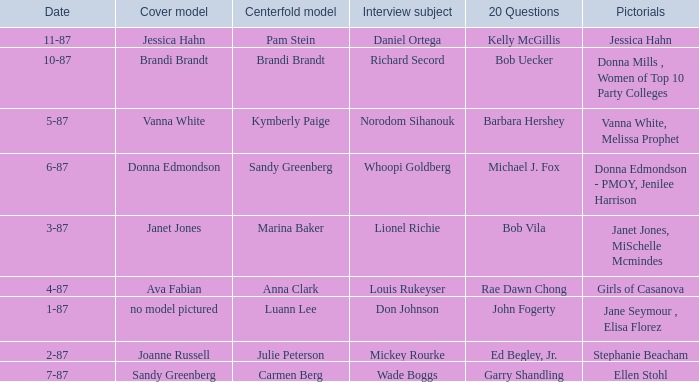When was the Kymberly Paige the Centerfold? 5-87. 